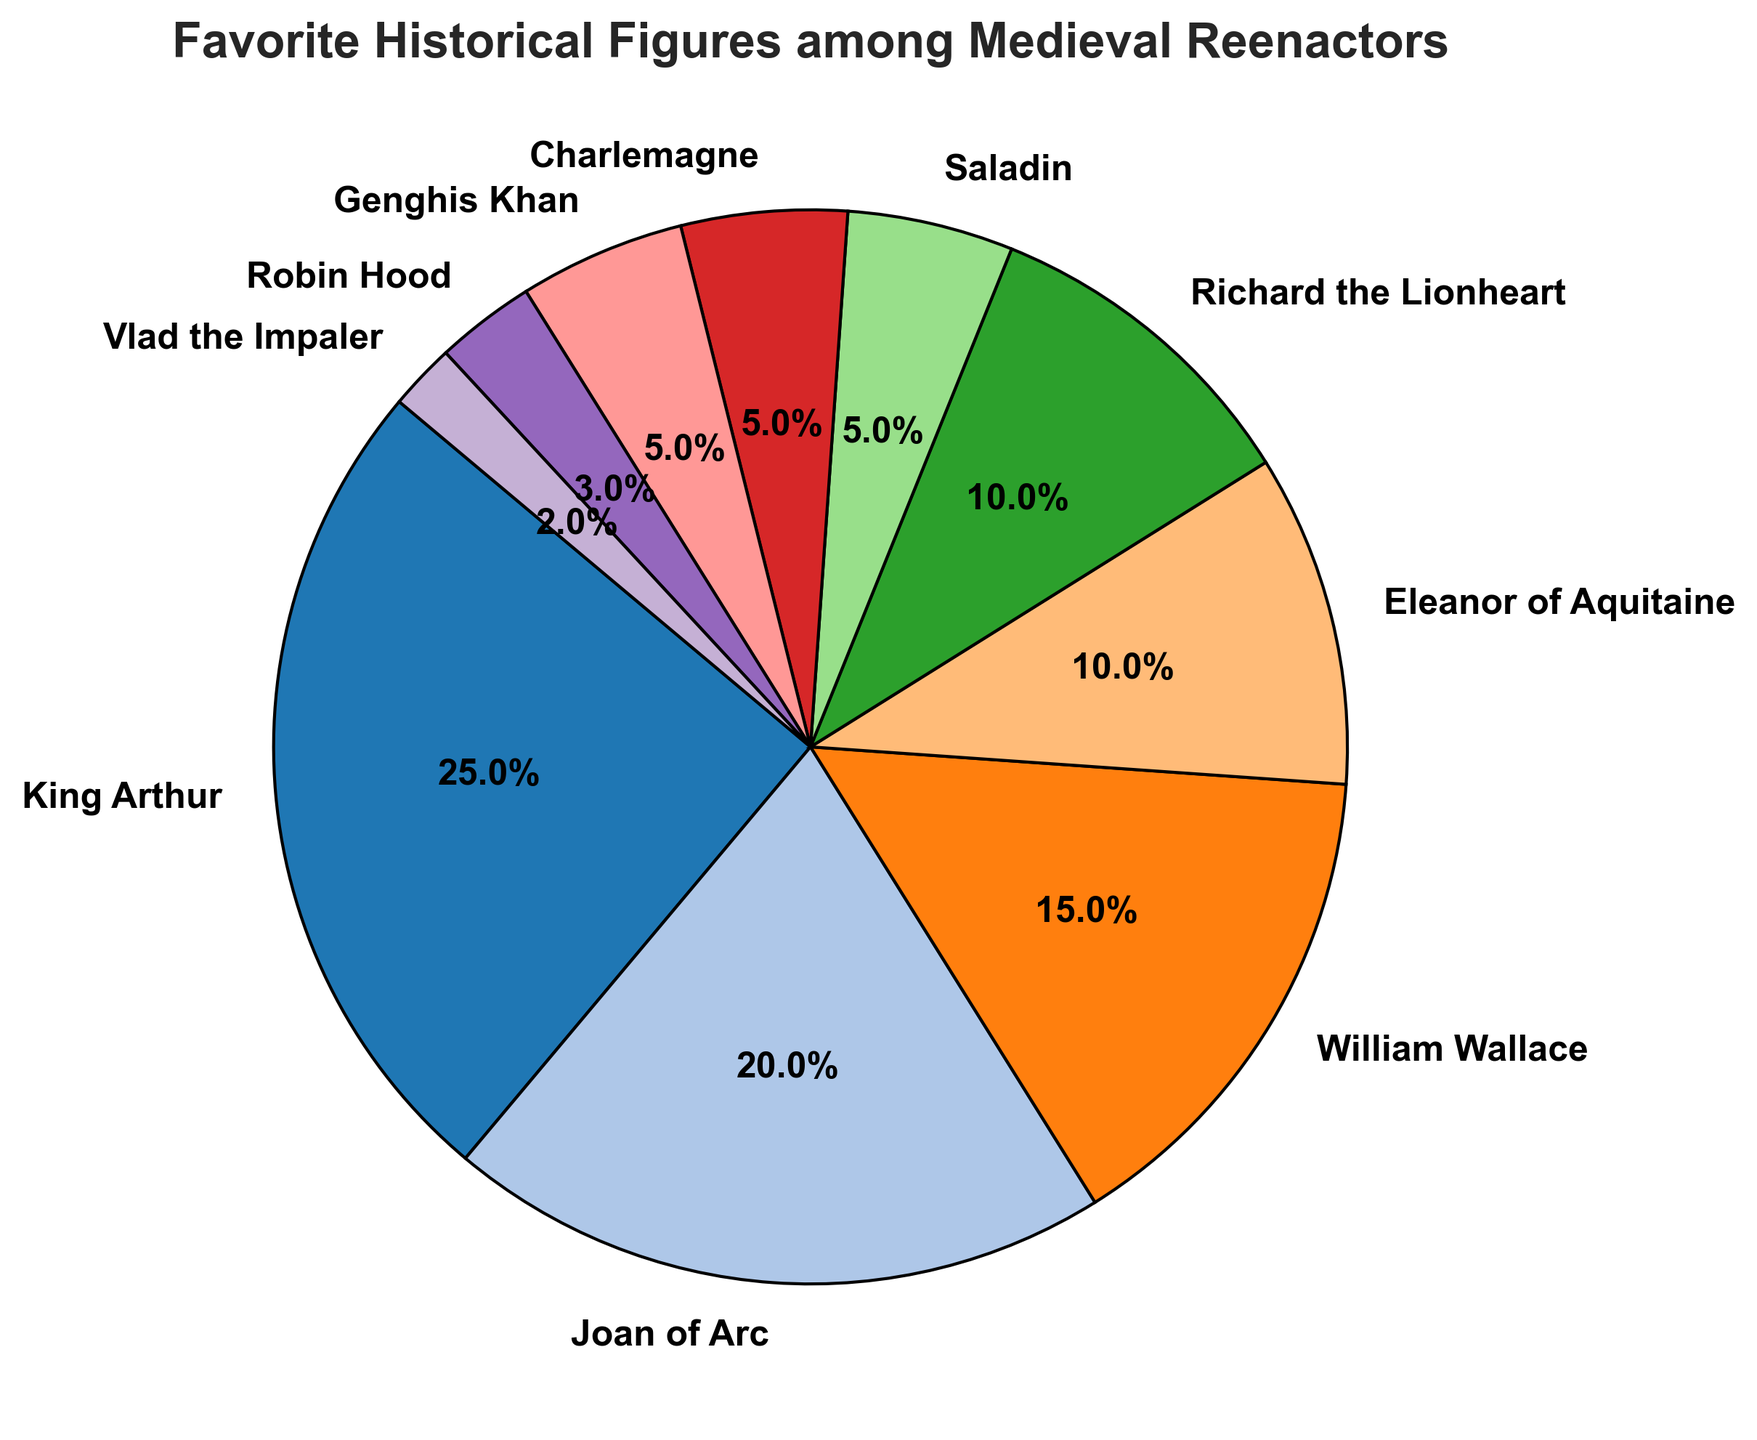Which historical figure is the most popular among medieval reenactors? Look at the section with the largest percentage. King Arthur has the largest slice of the pie chart with 25%.
Answer: King Arthur Which historical figure is the least popular among medieval reenactors? Identify the smallest section in the pie chart. Vlad the Impaler has the smallest slice with 2%.
Answer: Vlad the Impaler How much more popular is King Arthur compared to Joan of Arc? Subtract the percentage of Joan of Arc from that of King Arthur: 25% - 20% = 5%.
Answer: 5% What is the combined percentage of people who prefer William Wallace and Eleanor of Aquitaine? Add the percentages of William Wallace and Eleanor of Aquitaine: 15% + 10% = 25%.
Answer: 25% Which historical figures are tied in popularity? Find figures with identical percentages. Based on the chart, Charlemagne, Saladin, and Genghis Khan each have 5%.
Answer: Charlemagne, Saladin, Genghis Khan If you combine the popularity of Richard the Lionheart and Saladin, does it exceed King Arthur’s popularity? Add the percentages of Richard the Lionheart (10%) and Saladin (5%). Compare this sum (15%) to King Arthur's 25%.
Answer: No How much more popular is Robin Hood compared to Vlad the Impaler? Subtract Vlad the Impaler's percentage from Robin Hood's: 3% - 2% = 1%.
Answer: 1% What is the difference in popularity between the most and least popular figures? Subtract the percentage of the least popular figure (2%, Vlad the Impaler) from the percentage of the most popular figure (25%, King Arthur): 25% - 2% = 23%.
Answer: 23% How many figures have a popularity of 10% or higher? Count the sections with percentages 10% or above: King Arthur, Joan of Arc, William Wallace, Eleanor of Aquitaine, Richard the Lionheart. There are 5 figures in total.
Answer: 5 